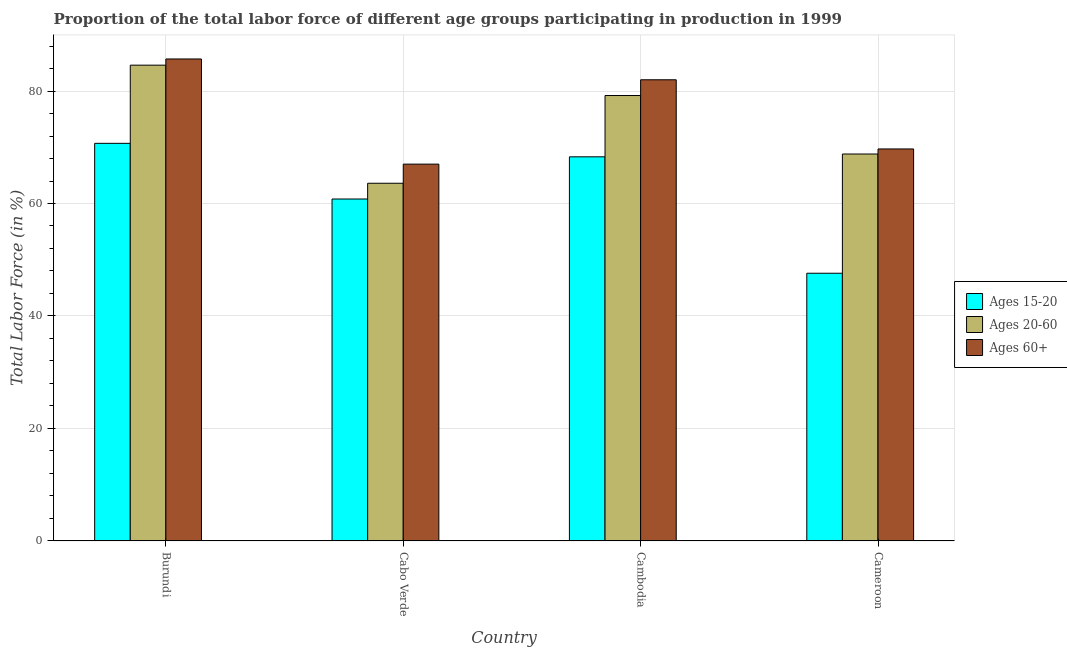How many different coloured bars are there?
Make the answer very short. 3. Are the number of bars per tick equal to the number of legend labels?
Ensure brevity in your answer.  Yes. What is the label of the 3rd group of bars from the left?
Offer a terse response. Cambodia. What is the percentage of labor force within the age group 20-60 in Burundi?
Your response must be concise. 84.6. Across all countries, what is the maximum percentage of labor force within the age group 20-60?
Provide a succinct answer. 84.6. Across all countries, what is the minimum percentage of labor force above age 60?
Provide a succinct answer. 67. In which country was the percentage of labor force within the age group 15-20 maximum?
Give a very brief answer. Burundi. In which country was the percentage of labor force above age 60 minimum?
Provide a succinct answer. Cabo Verde. What is the total percentage of labor force within the age group 15-20 in the graph?
Offer a very short reply. 247.4. What is the difference between the percentage of labor force within the age group 15-20 in Cambodia and the percentage of labor force above age 60 in Burundi?
Your response must be concise. -17.4. What is the average percentage of labor force within the age group 15-20 per country?
Your response must be concise. 61.85. What is the difference between the percentage of labor force above age 60 and percentage of labor force within the age group 20-60 in Cameroon?
Your response must be concise. 0.9. In how many countries, is the percentage of labor force above age 60 greater than 76 %?
Your answer should be compact. 2. What is the ratio of the percentage of labor force within the age group 15-20 in Burundi to that in Cabo Verde?
Your response must be concise. 1.16. Is the difference between the percentage of labor force within the age group 15-20 in Cabo Verde and Cameroon greater than the difference between the percentage of labor force above age 60 in Cabo Verde and Cameroon?
Make the answer very short. Yes. What is the difference between the highest and the second highest percentage of labor force above age 60?
Your answer should be compact. 3.7. What is the difference between the highest and the lowest percentage of labor force above age 60?
Your response must be concise. 18.7. In how many countries, is the percentage of labor force within the age group 20-60 greater than the average percentage of labor force within the age group 20-60 taken over all countries?
Provide a short and direct response. 2. What does the 1st bar from the left in Burundi represents?
Your answer should be compact. Ages 15-20. What does the 1st bar from the right in Cameroon represents?
Offer a terse response. Ages 60+. How many bars are there?
Provide a succinct answer. 12. Are all the bars in the graph horizontal?
Your response must be concise. No. How many countries are there in the graph?
Offer a very short reply. 4. What is the difference between two consecutive major ticks on the Y-axis?
Offer a terse response. 20. Does the graph contain any zero values?
Give a very brief answer. No. Does the graph contain grids?
Make the answer very short. Yes. How many legend labels are there?
Your answer should be very brief. 3. What is the title of the graph?
Make the answer very short. Proportion of the total labor force of different age groups participating in production in 1999. What is the Total Labor Force (in %) in Ages 15-20 in Burundi?
Provide a succinct answer. 70.7. What is the Total Labor Force (in %) in Ages 20-60 in Burundi?
Offer a terse response. 84.6. What is the Total Labor Force (in %) in Ages 60+ in Burundi?
Your response must be concise. 85.7. What is the Total Labor Force (in %) of Ages 15-20 in Cabo Verde?
Ensure brevity in your answer.  60.8. What is the Total Labor Force (in %) of Ages 20-60 in Cabo Verde?
Provide a succinct answer. 63.6. What is the Total Labor Force (in %) in Ages 60+ in Cabo Verde?
Offer a very short reply. 67. What is the Total Labor Force (in %) in Ages 15-20 in Cambodia?
Offer a terse response. 68.3. What is the Total Labor Force (in %) in Ages 20-60 in Cambodia?
Ensure brevity in your answer.  79.2. What is the Total Labor Force (in %) of Ages 15-20 in Cameroon?
Ensure brevity in your answer.  47.6. What is the Total Labor Force (in %) in Ages 20-60 in Cameroon?
Give a very brief answer. 68.8. What is the Total Labor Force (in %) in Ages 60+ in Cameroon?
Ensure brevity in your answer.  69.7. Across all countries, what is the maximum Total Labor Force (in %) in Ages 15-20?
Provide a succinct answer. 70.7. Across all countries, what is the maximum Total Labor Force (in %) of Ages 20-60?
Offer a terse response. 84.6. Across all countries, what is the maximum Total Labor Force (in %) in Ages 60+?
Offer a terse response. 85.7. Across all countries, what is the minimum Total Labor Force (in %) of Ages 15-20?
Provide a short and direct response. 47.6. Across all countries, what is the minimum Total Labor Force (in %) in Ages 20-60?
Provide a short and direct response. 63.6. What is the total Total Labor Force (in %) in Ages 15-20 in the graph?
Provide a succinct answer. 247.4. What is the total Total Labor Force (in %) of Ages 20-60 in the graph?
Make the answer very short. 296.2. What is the total Total Labor Force (in %) in Ages 60+ in the graph?
Keep it short and to the point. 304.4. What is the difference between the Total Labor Force (in %) of Ages 15-20 in Burundi and that in Cambodia?
Give a very brief answer. 2.4. What is the difference between the Total Labor Force (in %) of Ages 15-20 in Burundi and that in Cameroon?
Give a very brief answer. 23.1. What is the difference between the Total Labor Force (in %) of Ages 20-60 in Burundi and that in Cameroon?
Offer a very short reply. 15.8. What is the difference between the Total Labor Force (in %) in Ages 60+ in Burundi and that in Cameroon?
Ensure brevity in your answer.  16. What is the difference between the Total Labor Force (in %) of Ages 20-60 in Cabo Verde and that in Cambodia?
Your response must be concise. -15.6. What is the difference between the Total Labor Force (in %) of Ages 60+ in Cabo Verde and that in Cambodia?
Ensure brevity in your answer.  -15. What is the difference between the Total Labor Force (in %) in Ages 15-20 in Cabo Verde and that in Cameroon?
Your answer should be very brief. 13.2. What is the difference between the Total Labor Force (in %) in Ages 60+ in Cabo Verde and that in Cameroon?
Ensure brevity in your answer.  -2.7. What is the difference between the Total Labor Force (in %) in Ages 15-20 in Cambodia and that in Cameroon?
Keep it short and to the point. 20.7. What is the difference between the Total Labor Force (in %) in Ages 20-60 in Cambodia and that in Cameroon?
Your response must be concise. 10.4. What is the difference between the Total Labor Force (in %) in Ages 60+ in Cambodia and that in Cameroon?
Make the answer very short. 12.3. What is the difference between the Total Labor Force (in %) of Ages 15-20 in Burundi and the Total Labor Force (in %) of Ages 60+ in Cabo Verde?
Your response must be concise. 3.7. What is the difference between the Total Labor Force (in %) in Ages 20-60 in Burundi and the Total Labor Force (in %) in Ages 60+ in Cabo Verde?
Provide a short and direct response. 17.6. What is the difference between the Total Labor Force (in %) in Ages 15-20 in Burundi and the Total Labor Force (in %) in Ages 20-60 in Cambodia?
Your answer should be compact. -8.5. What is the difference between the Total Labor Force (in %) in Ages 15-20 in Burundi and the Total Labor Force (in %) in Ages 60+ in Cambodia?
Keep it short and to the point. -11.3. What is the difference between the Total Labor Force (in %) of Ages 20-60 in Burundi and the Total Labor Force (in %) of Ages 60+ in Cambodia?
Offer a terse response. 2.6. What is the difference between the Total Labor Force (in %) of Ages 20-60 in Burundi and the Total Labor Force (in %) of Ages 60+ in Cameroon?
Ensure brevity in your answer.  14.9. What is the difference between the Total Labor Force (in %) of Ages 15-20 in Cabo Verde and the Total Labor Force (in %) of Ages 20-60 in Cambodia?
Make the answer very short. -18.4. What is the difference between the Total Labor Force (in %) of Ages 15-20 in Cabo Verde and the Total Labor Force (in %) of Ages 60+ in Cambodia?
Ensure brevity in your answer.  -21.2. What is the difference between the Total Labor Force (in %) of Ages 20-60 in Cabo Verde and the Total Labor Force (in %) of Ages 60+ in Cambodia?
Keep it short and to the point. -18.4. What is the difference between the Total Labor Force (in %) in Ages 15-20 in Cabo Verde and the Total Labor Force (in %) in Ages 60+ in Cameroon?
Provide a short and direct response. -8.9. What is the average Total Labor Force (in %) of Ages 15-20 per country?
Offer a terse response. 61.85. What is the average Total Labor Force (in %) of Ages 20-60 per country?
Provide a succinct answer. 74.05. What is the average Total Labor Force (in %) of Ages 60+ per country?
Offer a very short reply. 76.1. What is the difference between the Total Labor Force (in %) of Ages 15-20 and Total Labor Force (in %) of Ages 20-60 in Burundi?
Offer a very short reply. -13.9. What is the difference between the Total Labor Force (in %) in Ages 15-20 and Total Labor Force (in %) in Ages 60+ in Burundi?
Provide a succinct answer. -15. What is the difference between the Total Labor Force (in %) of Ages 20-60 and Total Labor Force (in %) of Ages 60+ in Burundi?
Your answer should be very brief. -1.1. What is the difference between the Total Labor Force (in %) of Ages 15-20 and Total Labor Force (in %) of Ages 20-60 in Cabo Verde?
Offer a terse response. -2.8. What is the difference between the Total Labor Force (in %) of Ages 15-20 and Total Labor Force (in %) of Ages 20-60 in Cambodia?
Offer a terse response. -10.9. What is the difference between the Total Labor Force (in %) in Ages 15-20 and Total Labor Force (in %) in Ages 60+ in Cambodia?
Your answer should be very brief. -13.7. What is the difference between the Total Labor Force (in %) of Ages 15-20 and Total Labor Force (in %) of Ages 20-60 in Cameroon?
Your answer should be compact. -21.2. What is the difference between the Total Labor Force (in %) in Ages 15-20 and Total Labor Force (in %) in Ages 60+ in Cameroon?
Your response must be concise. -22.1. What is the difference between the Total Labor Force (in %) in Ages 20-60 and Total Labor Force (in %) in Ages 60+ in Cameroon?
Your response must be concise. -0.9. What is the ratio of the Total Labor Force (in %) in Ages 15-20 in Burundi to that in Cabo Verde?
Your answer should be compact. 1.16. What is the ratio of the Total Labor Force (in %) of Ages 20-60 in Burundi to that in Cabo Verde?
Give a very brief answer. 1.33. What is the ratio of the Total Labor Force (in %) of Ages 60+ in Burundi to that in Cabo Verde?
Your answer should be very brief. 1.28. What is the ratio of the Total Labor Force (in %) of Ages 15-20 in Burundi to that in Cambodia?
Offer a terse response. 1.04. What is the ratio of the Total Labor Force (in %) of Ages 20-60 in Burundi to that in Cambodia?
Keep it short and to the point. 1.07. What is the ratio of the Total Labor Force (in %) of Ages 60+ in Burundi to that in Cambodia?
Ensure brevity in your answer.  1.05. What is the ratio of the Total Labor Force (in %) in Ages 15-20 in Burundi to that in Cameroon?
Provide a succinct answer. 1.49. What is the ratio of the Total Labor Force (in %) of Ages 20-60 in Burundi to that in Cameroon?
Your response must be concise. 1.23. What is the ratio of the Total Labor Force (in %) in Ages 60+ in Burundi to that in Cameroon?
Provide a short and direct response. 1.23. What is the ratio of the Total Labor Force (in %) in Ages 15-20 in Cabo Verde to that in Cambodia?
Offer a terse response. 0.89. What is the ratio of the Total Labor Force (in %) of Ages 20-60 in Cabo Verde to that in Cambodia?
Give a very brief answer. 0.8. What is the ratio of the Total Labor Force (in %) in Ages 60+ in Cabo Verde to that in Cambodia?
Ensure brevity in your answer.  0.82. What is the ratio of the Total Labor Force (in %) of Ages 15-20 in Cabo Verde to that in Cameroon?
Give a very brief answer. 1.28. What is the ratio of the Total Labor Force (in %) in Ages 20-60 in Cabo Verde to that in Cameroon?
Offer a terse response. 0.92. What is the ratio of the Total Labor Force (in %) in Ages 60+ in Cabo Verde to that in Cameroon?
Your response must be concise. 0.96. What is the ratio of the Total Labor Force (in %) in Ages 15-20 in Cambodia to that in Cameroon?
Offer a very short reply. 1.43. What is the ratio of the Total Labor Force (in %) of Ages 20-60 in Cambodia to that in Cameroon?
Provide a short and direct response. 1.15. What is the ratio of the Total Labor Force (in %) in Ages 60+ in Cambodia to that in Cameroon?
Keep it short and to the point. 1.18. What is the difference between the highest and the second highest Total Labor Force (in %) of Ages 60+?
Provide a succinct answer. 3.7. What is the difference between the highest and the lowest Total Labor Force (in %) in Ages 15-20?
Provide a succinct answer. 23.1. What is the difference between the highest and the lowest Total Labor Force (in %) in Ages 60+?
Offer a terse response. 18.7. 